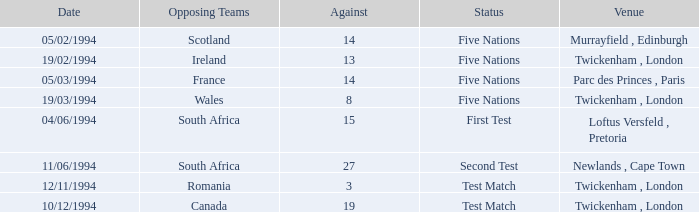Which venue has more than 19 against? Newlands , Cape Town. 